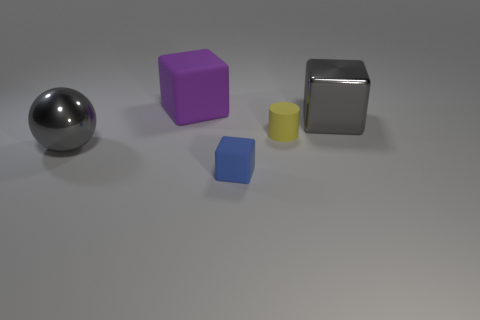What number of red metal blocks are there?
Provide a short and direct response. 0. What is the color of the other cube that is the same size as the purple matte block?
Your answer should be very brief. Gray. Does the blue rubber object have the same size as the cylinder?
Offer a terse response. Yes. The object that is the same color as the metal sphere is what shape?
Your response must be concise. Cube. Do the cylinder and the gray metal object that is to the left of the large matte cube have the same size?
Offer a terse response. No. There is a block that is both behind the tiny rubber cube and left of the large metal block; what color is it?
Offer a very short reply. Purple. Are there more rubber cubes that are behind the large gray ball than large metal balls that are in front of the large gray shiny block?
Ensure brevity in your answer.  No. There is a blue thing that is made of the same material as the tiny yellow thing; what is its size?
Your response must be concise. Small. What number of purple things are in front of the gray object to the left of the blue object?
Give a very brief answer. 0. Is there another small blue matte object of the same shape as the blue rubber object?
Offer a terse response. No. 